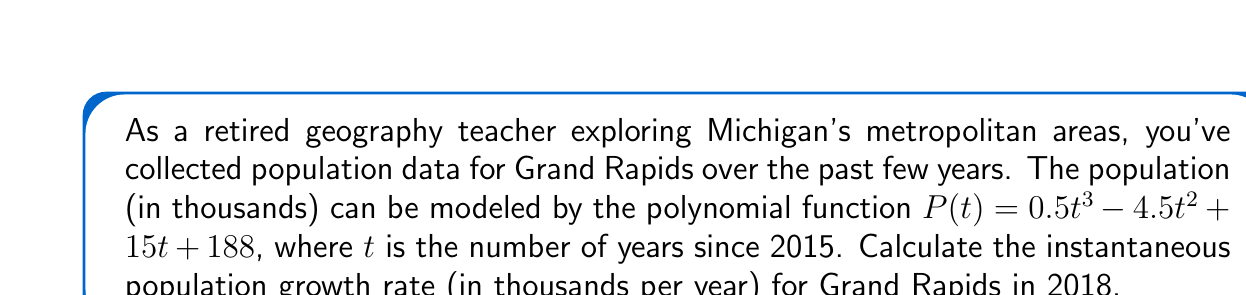Could you help me with this problem? To find the instantaneous population growth rate in 2018, we need to follow these steps:

1) The instantaneous growth rate is given by the derivative of the population function at the specific time.

2) First, let's find the derivative of $P(t)$:
   $$P'(t) = 1.5t^2 - 9t + 15$$

3) We need to evaluate this at $t = 3$, because 2018 is 3 years after 2015.

4) Substituting $t = 3$ into the derivative:
   $$P'(3) = 1.5(3)^2 - 9(3) + 15$$
   $$= 1.5(9) - 27 + 15$$
   $$= 13.5 - 27 + 15$$
   $$= 1.5$$

5) Therefore, the instantaneous growth rate in 2018 is 1.5 thousand people per year.
Answer: $1.5$ thousand people per year 